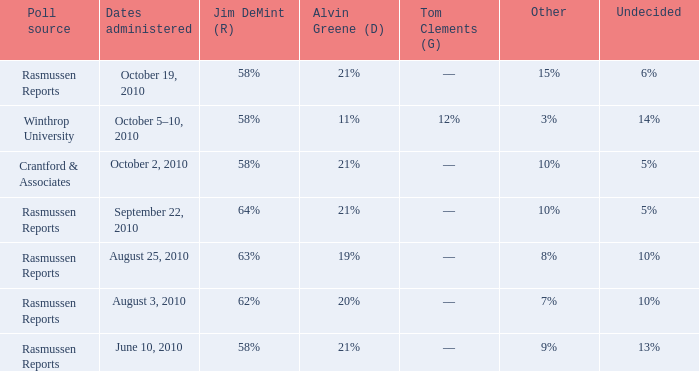Which poll source determined undecided of 5% and Jim DeMint (R) of 58%? Crantford & Associates. 